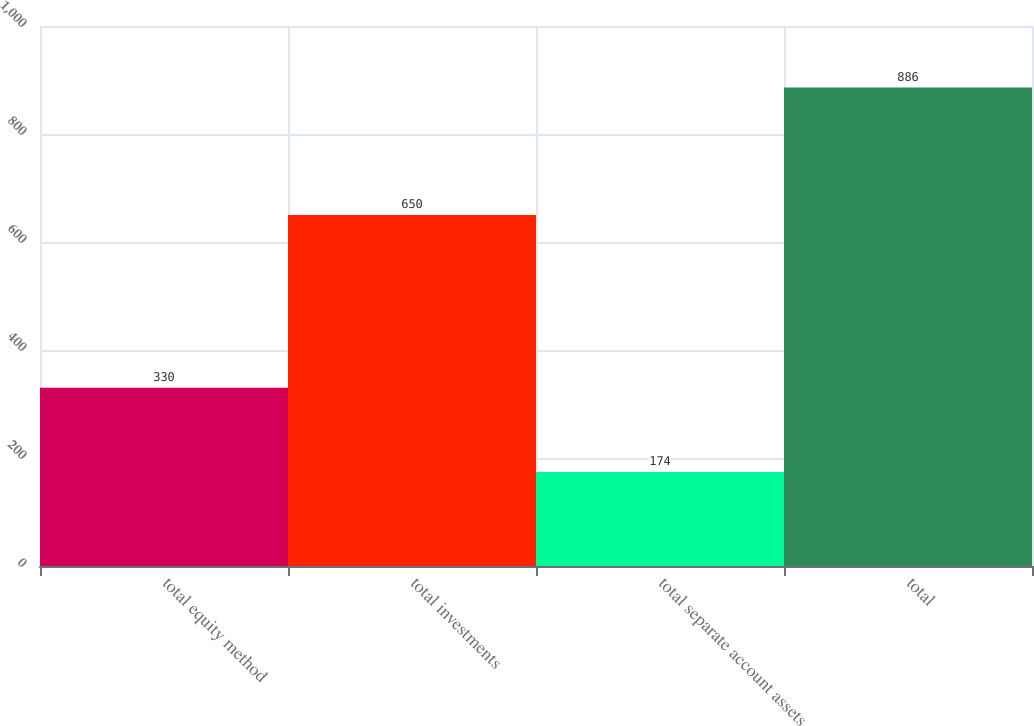Convert chart. <chart><loc_0><loc_0><loc_500><loc_500><bar_chart><fcel>total equity method<fcel>total investments<fcel>total separate account assets<fcel>total<nl><fcel>330<fcel>650<fcel>174<fcel>886<nl></chart> 